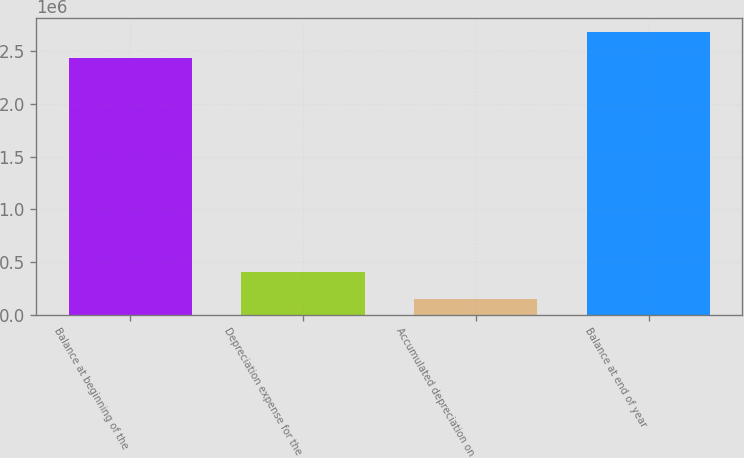Convert chart. <chart><loc_0><loc_0><loc_500><loc_500><bar_chart><fcel>Balance at beginning of the<fcel>Depreciation expense for the<fcel>Accumulated depreciation on<fcel>Balance at end of year<nl><fcel>2.43477e+06<fcel>401955<fcel>152520<fcel>2.68421e+06<nl></chart> 